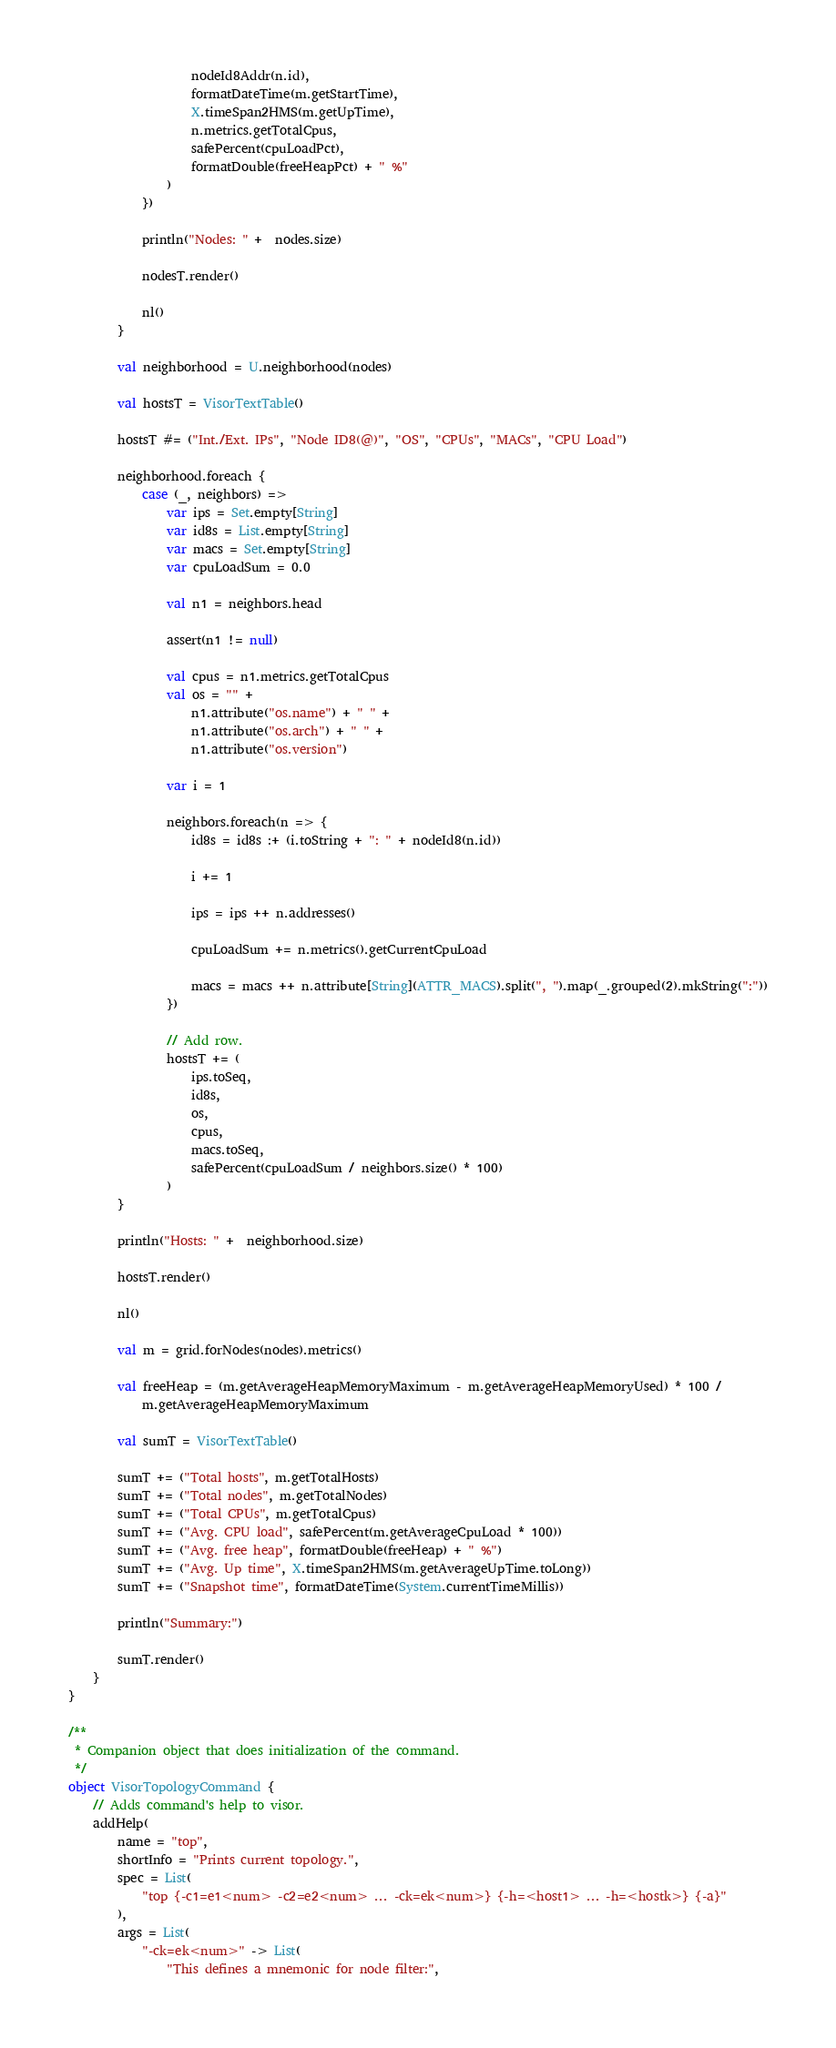Convert code to text. <code><loc_0><loc_0><loc_500><loc_500><_Scala_>                    nodeId8Addr(n.id),
                    formatDateTime(m.getStartTime),
                    X.timeSpan2HMS(m.getUpTime),
                    n.metrics.getTotalCpus,
                    safePercent(cpuLoadPct),
                    formatDouble(freeHeapPct) + " %"
                )
            })

            println("Nodes: " +  nodes.size)

            nodesT.render()

            nl()
        }

        val neighborhood = U.neighborhood(nodes)

        val hostsT = VisorTextTable()

        hostsT #= ("Int./Ext. IPs", "Node ID8(@)", "OS", "CPUs", "MACs", "CPU Load")

        neighborhood.foreach {
            case (_, neighbors) =>
                var ips = Set.empty[String]
                var id8s = List.empty[String]
                var macs = Set.empty[String]
                var cpuLoadSum = 0.0

                val n1 = neighbors.head

                assert(n1 != null)

                val cpus = n1.metrics.getTotalCpus
                val os = "" +
                    n1.attribute("os.name") + " " +
                    n1.attribute("os.arch") + " " +
                    n1.attribute("os.version")

                var i = 1

                neighbors.foreach(n => {
                    id8s = id8s :+ (i.toString + ": " + nodeId8(n.id))

                    i += 1

                    ips = ips ++ n.addresses()

                    cpuLoadSum += n.metrics().getCurrentCpuLoad

                    macs = macs ++ n.attribute[String](ATTR_MACS).split(", ").map(_.grouped(2).mkString(":"))
                })

                // Add row.
                hostsT += (
                    ips.toSeq,
                    id8s,
                    os,
                    cpus,
                    macs.toSeq,
                    safePercent(cpuLoadSum / neighbors.size() * 100)
                )
        }

        println("Hosts: " +  neighborhood.size)

        hostsT.render()

        nl()

        val m = grid.forNodes(nodes).metrics()

        val freeHeap = (m.getAverageHeapMemoryMaximum - m.getAverageHeapMemoryUsed) * 100 /
            m.getAverageHeapMemoryMaximum

        val sumT = VisorTextTable()

        sumT += ("Total hosts", m.getTotalHosts)
        sumT += ("Total nodes", m.getTotalNodes)
        sumT += ("Total CPUs", m.getTotalCpus)
        sumT += ("Avg. CPU load", safePercent(m.getAverageCpuLoad * 100))
        sumT += ("Avg. free heap", formatDouble(freeHeap) + " %")
        sumT += ("Avg. Up time", X.timeSpan2HMS(m.getAverageUpTime.toLong))
        sumT += ("Snapshot time", formatDateTime(System.currentTimeMillis))

        println("Summary:")

        sumT.render()
    }
}

/**
 * Companion object that does initialization of the command.
 */
object VisorTopologyCommand {
    // Adds command's help to visor.
    addHelp(
        name = "top",
        shortInfo = "Prints current topology.",
        spec = List(
            "top {-c1=e1<num> -c2=e2<num> ... -ck=ek<num>} {-h=<host1> ... -h=<hostk>} {-a}"
        ),
        args = List(
            "-ck=ek<num>" -> List(
                "This defines a mnemonic for node filter:",</code> 